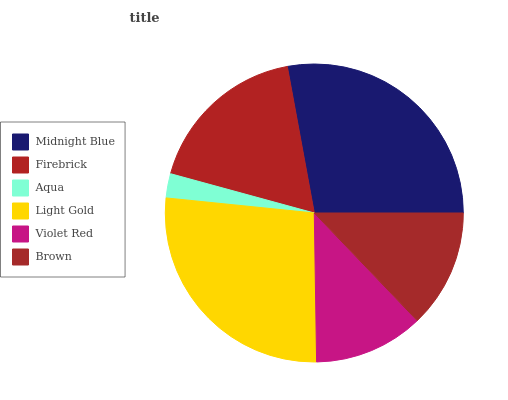Is Aqua the minimum?
Answer yes or no. Yes. Is Midnight Blue the maximum?
Answer yes or no. Yes. Is Firebrick the minimum?
Answer yes or no. No. Is Firebrick the maximum?
Answer yes or no. No. Is Midnight Blue greater than Firebrick?
Answer yes or no. Yes. Is Firebrick less than Midnight Blue?
Answer yes or no. Yes. Is Firebrick greater than Midnight Blue?
Answer yes or no. No. Is Midnight Blue less than Firebrick?
Answer yes or no. No. Is Firebrick the high median?
Answer yes or no. Yes. Is Brown the low median?
Answer yes or no. Yes. Is Midnight Blue the high median?
Answer yes or no. No. Is Violet Red the low median?
Answer yes or no. No. 